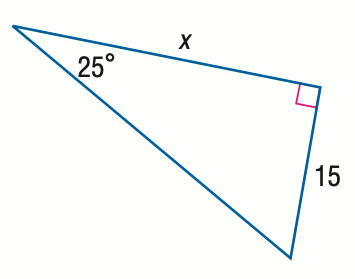Question: Find x.
Choices:
A. 7.0
B. 16.6
C. 32.2
D. 35.5
Answer with the letter. Answer: C 